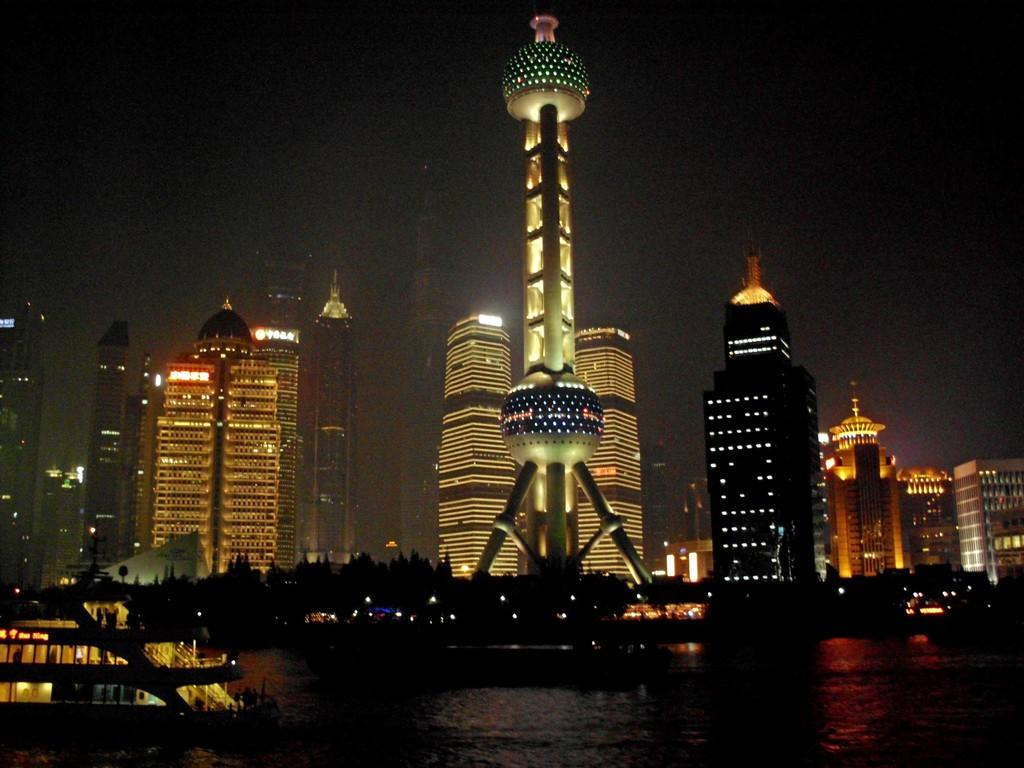What is the main subject of the image? The main subject of the image is a boat. Where is the boat located? The boat is on the water. What other objects or structures can be seen in the image? There are trees, a tower, and buildings in the image. What type of jelly is being used to decorate the tower in the image? There is no jelly present in the image, and the tower is not being decorated. 